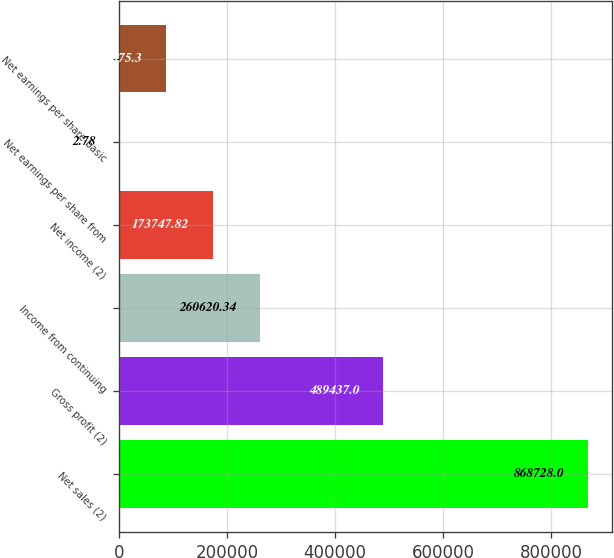Convert chart. <chart><loc_0><loc_0><loc_500><loc_500><bar_chart><fcel>Net sales (2)<fcel>Gross profit (2)<fcel>Income from continuing<fcel>Net income (2)<fcel>Net earnings per share from<fcel>Net earnings per share-basic<nl><fcel>868728<fcel>489437<fcel>260620<fcel>173748<fcel>2.78<fcel>86875.3<nl></chart> 